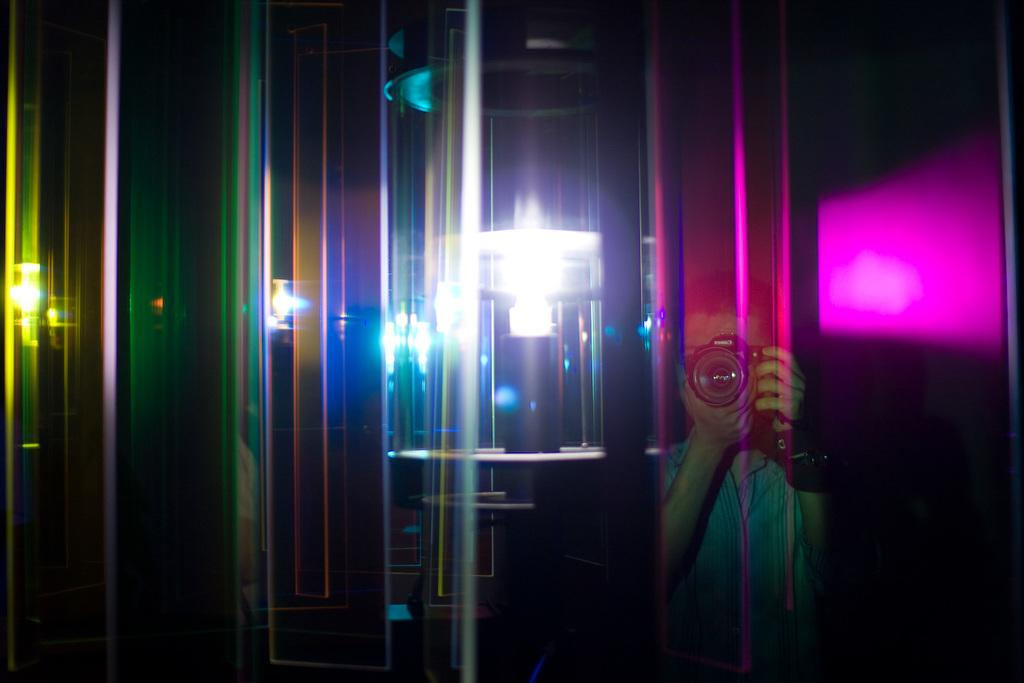What is the main subject of the image? There is a person in the image. What is the person holding in the image? The person is holding a camera. What can be seen in the middle of the image? There is a lightning block in the middle of the image. What type of quartz can be seen in the image? There is no quartz present in the image. How does the person fold the lightning block in the image? The image does not show the person folding the lightning block, as it is a stationary object. 